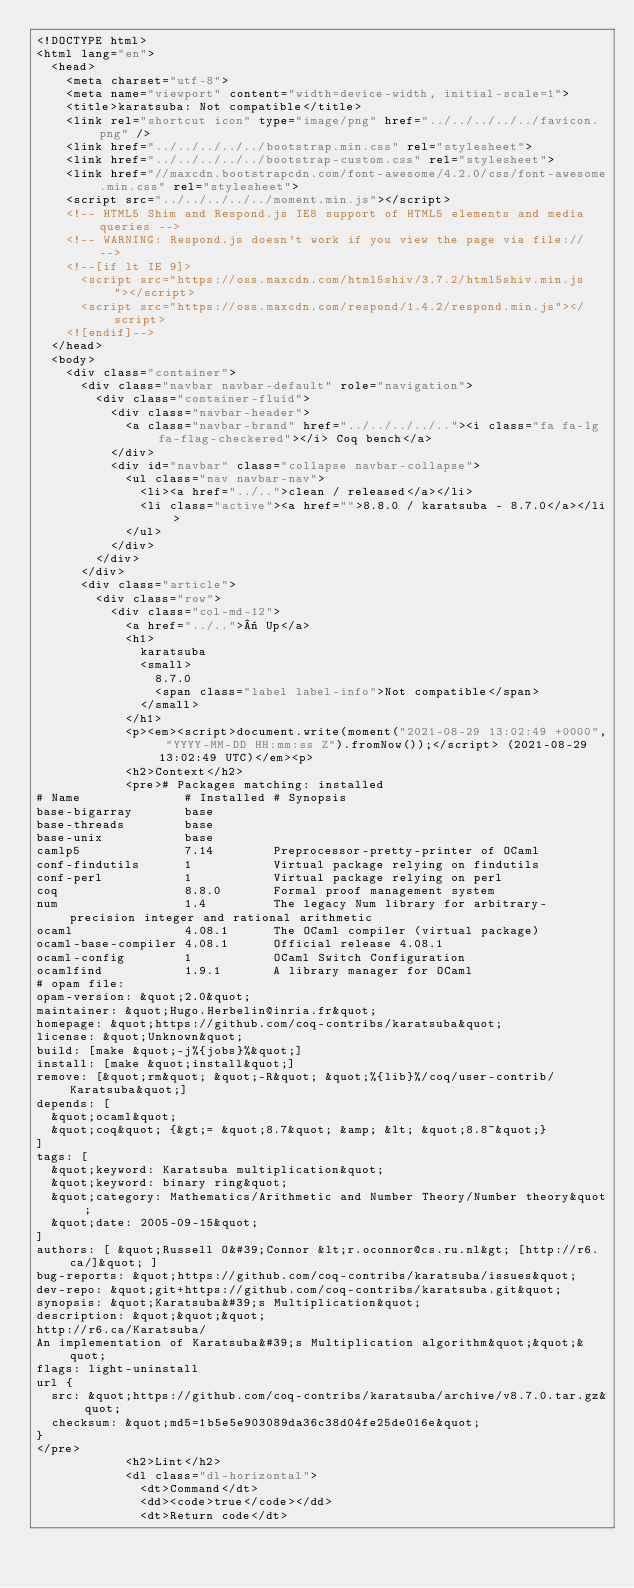Convert code to text. <code><loc_0><loc_0><loc_500><loc_500><_HTML_><!DOCTYPE html>
<html lang="en">
  <head>
    <meta charset="utf-8">
    <meta name="viewport" content="width=device-width, initial-scale=1">
    <title>karatsuba: Not compatible</title>
    <link rel="shortcut icon" type="image/png" href="../../../../../favicon.png" />
    <link href="../../../../../bootstrap.min.css" rel="stylesheet">
    <link href="../../../../../bootstrap-custom.css" rel="stylesheet">
    <link href="//maxcdn.bootstrapcdn.com/font-awesome/4.2.0/css/font-awesome.min.css" rel="stylesheet">
    <script src="../../../../../moment.min.js"></script>
    <!-- HTML5 Shim and Respond.js IE8 support of HTML5 elements and media queries -->
    <!-- WARNING: Respond.js doesn't work if you view the page via file:// -->
    <!--[if lt IE 9]>
      <script src="https://oss.maxcdn.com/html5shiv/3.7.2/html5shiv.min.js"></script>
      <script src="https://oss.maxcdn.com/respond/1.4.2/respond.min.js"></script>
    <![endif]-->
  </head>
  <body>
    <div class="container">
      <div class="navbar navbar-default" role="navigation">
        <div class="container-fluid">
          <div class="navbar-header">
            <a class="navbar-brand" href="../../../../.."><i class="fa fa-lg fa-flag-checkered"></i> Coq bench</a>
          </div>
          <div id="navbar" class="collapse navbar-collapse">
            <ul class="nav navbar-nav">
              <li><a href="../..">clean / released</a></li>
              <li class="active"><a href="">8.8.0 / karatsuba - 8.7.0</a></li>
            </ul>
          </div>
        </div>
      </div>
      <div class="article">
        <div class="row">
          <div class="col-md-12">
            <a href="../..">« Up</a>
            <h1>
              karatsuba
              <small>
                8.7.0
                <span class="label label-info">Not compatible</span>
              </small>
            </h1>
            <p><em><script>document.write(moment("2021-08-29 13:02:49 +0000", "YYYY-MM-DD HH:mm:ss Z").fromNow());</script> (2021-08-29 13:02:49 UTC)</em><p>
            <h2>Context</h2>
            <pre># Packages matching: installed
# Name              # Installed # Synopsis
base-bigarray       base
base-threads        base
base-unix           base
camlp5              7.14        Preprocessor-pretty-printer of OCaml
conf-findutils      1           Virtual package relying on findutils
conf-perl           1           Virtual package relying on perl
coq                 8.8.0       Formal proof management system
num                 1.4         The legacy Num library for arbitrary-precision integer and rational arithmetic
ocaml               4.08.1      The OCaml compiler (virtual package)
ocaml-base-compiler 4.08.1      Official release 4.08.1
ocaml-config        1           OCaml Switch Configuration
ocamlfind           1.9.1       A library manager for OCaml
# opam file:
opam-version: &quot;2.0&quot;
maintainer: &quot;Hugo.Herbelin@inria.fr&quot;
homepage: &quot;https://github.com/coq-contribs/karatsuba&quot;
license: &quot;Unknown&quot;
build: [make &quot;-j%{jobs}%&quot;]
install: [make &quot;install&quot;]
remove: [&quot;rm&quot; &quot;-R&quot; &quot;%{lib}%/coq/user-contrib/Karatsuba&quot;]
depends: [
  &quot;ocaml&quot;
  &quot;coq&quot; {&gt;= &quot;8.7&quot; &amp; &lt; &quot;8.8~&quot;}
]
tags: [
  &quot;keyword: Karatsuba multiplication&quot;
  &quot;keyword: binary ring&quot;
  &quot;category: Mathematics/Arithmetic and Number Theory/Number theory&quot;
  &quot;date: 2005-09-15&quot;
]
authors: [ &quot;Russell O&#39;Connor &lt;r.oconnor@cs.ru.nl&gt; [http://r6.ca/]&quot; ]
bug-reports: &quot;https://github.com/coq-contribs/karatsuba/issues&quot;
dev-repo: &quot;git+https://github.com/coq-contribs/karatsuba.git&quot;
synopsis: &quot;Karatsuba&#39;s Multiplication&quot;
description: &quot;&quot;&quot;
http://r6.ca/Karatsuba/
An implementation of Karatsuba&#39;s Multiplication algorithm&quot;&quot;&quot;
flags: light-uninstall
url {
  src: &quot;https://github.com/coq-contribs/karatsuba/archive/v8.7.0.tar.gz&quot;
  checksum: &quot;md5=1b5e5e903089da36c38d04fe25de016e&quot;
}
</pre>
            <h2>Lint</h2>
            <dl class="dl-horizontal">
              <dt>Command</dt>
              <dd><code>true</code></dd>
              <dt>Return code</dt></code> 